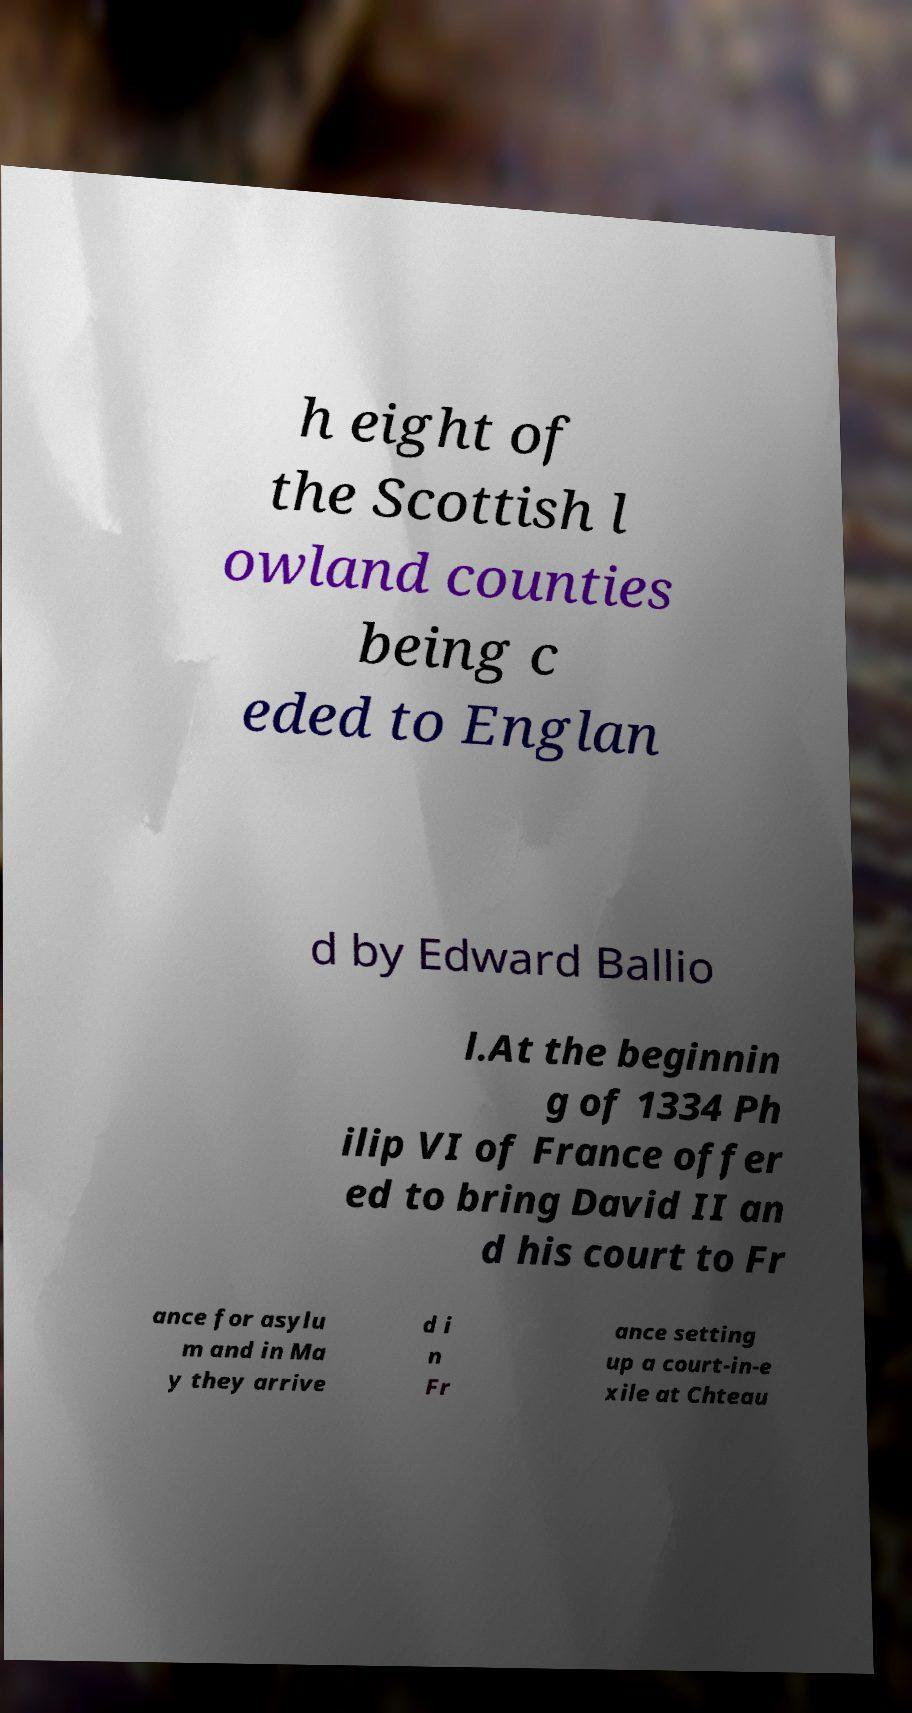There's text embedded in this image that I need extracted. Can you transcribe it verbatim? h eight of the Scottish l owland counties being c eded to Englan d by Edward Ballio l.At the beginnin g of 1334 Ph ilip VI of France offer ed to bring David II an d his court to Fr ance for asylu m and in Ma y they arrive d i n Fr ance setting up a court-in-e xile at Chteau 